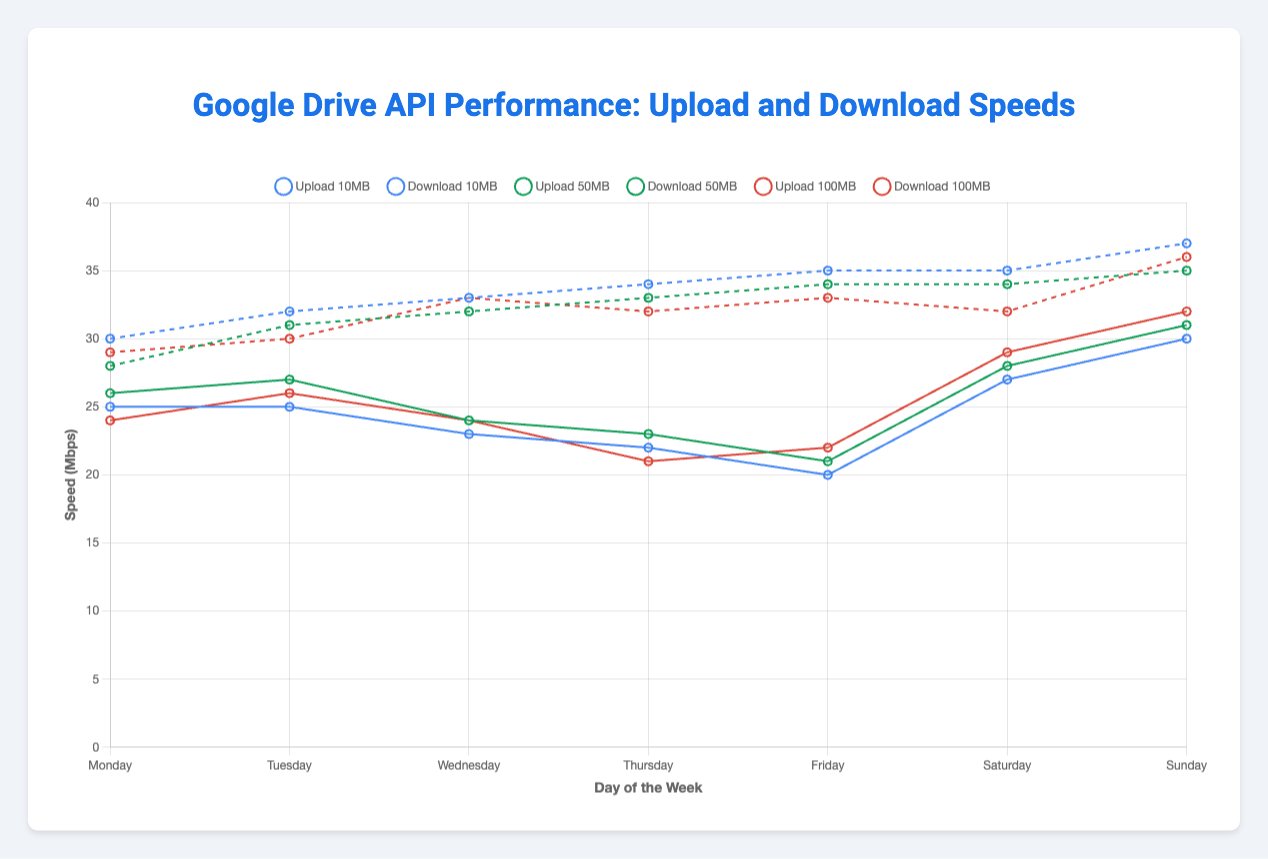Which day had the highest average upload speed for 10MB files? To find this, we examine each day for the upload speeds of 10MB files and compare their values. Monday (25), Tuesday (25), Wednesday (23), Thursday (22), Friday (20), Saturday (27), Sunday (30). Sunday has the highest value.
Answer: Sunday What is the difference in download speed between 100MB files on Wednesday and Thursday? Check the download speeds for 100MB files on both days. Wednesday (33) and Thursday (32). The difference is 33 - 32.
Answer: 1 Mbps Which day had the lowest upload speed for 50MB files, and what was the speed? Examine the upload speeds for 50MB files across each day. Monday (26), Tuesday (27), Wednesday (24), Thursday (23), Friday (21), Saturday (28), Sunday (31). Friday has the lowest speed at 21 Mbps.
Answer: Friday, 21 Mbps On Saturday, how does the download speed for 50MB files compare to the upload speed for 10MB files? On Saturday, the download speed for 50MB files is 34 Mbps, and the upload speed for 10MB files is 27 Mbps. The download speed is 7 Mbps faster.
Answer: Download speed is 7 Mbps faster What is the average download speed for 50MB files over the week? Sum of download speeds for 50MB files: 28 (Monday) + 31 (Tuesday) + 32 (Wednesday) + 33 (Thursday) + 34 (Friday) + 34 (Saturday) + 35 (Sunday) = 227 Mbps. There are 7 days, so the average is 227 / 7.
Answer: 32.43 Mbps Which file size had the most consistent upload speed over the week? Compare the range of upload speeds for each file size over the week. 10MB: [20, 30], 50MB: [21, 31], 100MB: [21, 32]. The range for 10MB files is the smallest (10 Mbps), indicating more consistent speed.
Answer: 10MB files How do the upload and download speeds for 100MB files on Sunday compare? On Sunday, the upload speed for 100MB files is 32 Mbps, and the download speed is 36 Mbps. The download speed is higher by 4 Mbps.
Answer: Download speed is higher by 4 Mbps What trends can be observed regarding upload speeds from Monday to Sunday? Analyzing the upload speeds for all file sizes from Monday to Sunday, there is a general increasing trend. For example, 10MB files: 25 (Mon), 25 (Tue), 23 (Wed), 22 (Thu), 20 (Fri), 27 (Sat), 30 (Sun); 50MB and 100MB files follow a similar pattern with a peak towards the weekend.
Answer: Increasing trend observed On which day do 10MB files have the highest download speed, and what is that speed? Check the download speeds for 10MB files across the days: Monday (30), Tuesday (32), Wednesday (33), Thursday (34), Friday (35), Saturday (35), Sunday (37). The highest speed is on Sunday with 37 Mbps.
Answer: Sunday, 37 Mbps What is the sum of download speeds for 100MB files on Monday and Tuesday? The download speeds for 100MB files are: Monday (29 Mbps) and Tuesday (30 Mbps). Sum them up to get 29 + 30.
Answer: 59 Mbps 